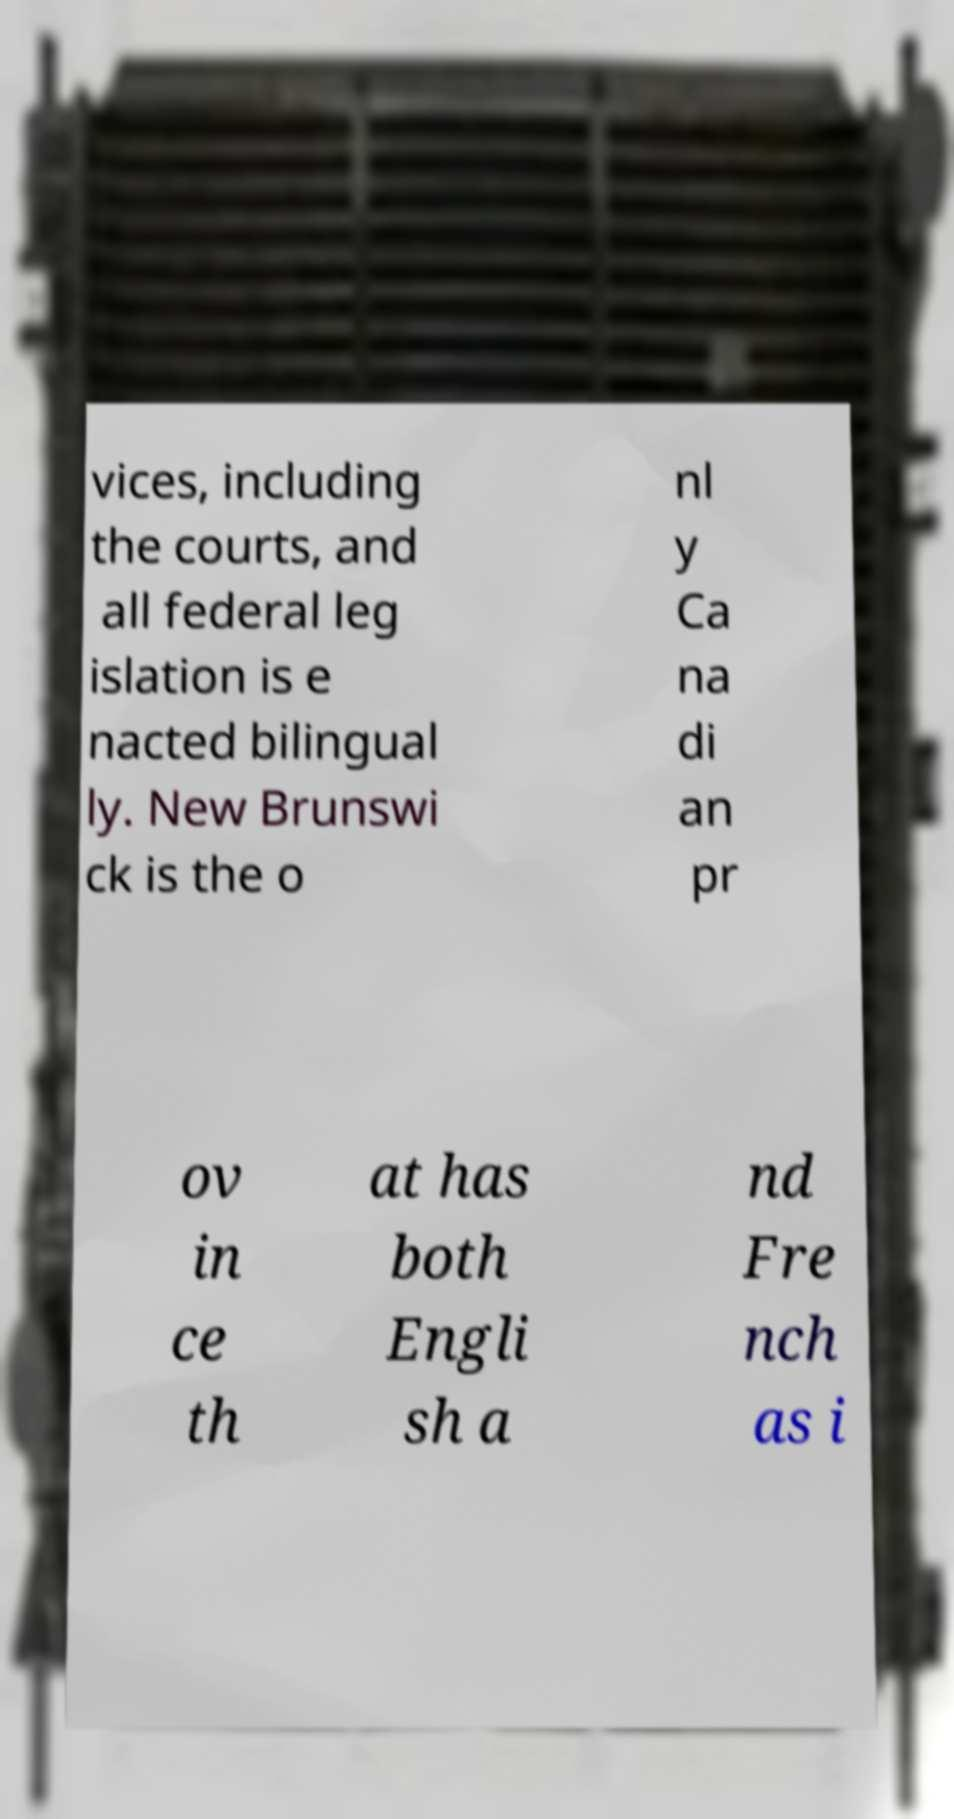There's text embedded in this image that I need extracted. Can you transcribe it verbatim? vices, including the courts, and all federal leg islation is e nacted bilingual ly. New Brunswi ck is the o nl y Ca na di an pr ov in ce th at has both Engli sh a nd Fre nch as i 